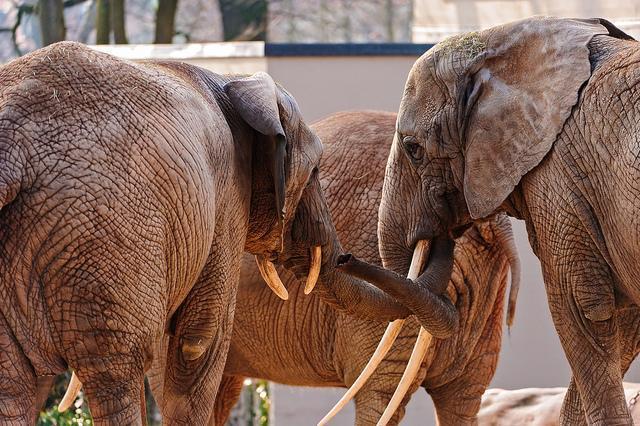How many big elephants are inside of this zoo enclosure together?
Pick the right solution, then justify: 'Answer: answer
Rationale: rationale.'
Options: One, four, two, three. Answer: three.
Rationale: There are no elephants fully visible. but several can be seen. 